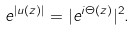<formula> <loc_0><loc_0><loc_500><loc_500>e ^ { | u ( z ) | } = | e ^ { i \Theta ( z ) } | ^ { 2 } .</formula> 